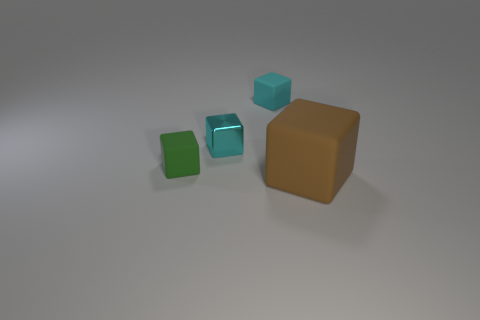Subtract all cyan rubber cubes. How many cubes are left? 3 Subtract all green cubes. How many cubes are left? 3 Subtract 0 blue cylinders. How many objects are left? 4 Subtract 2 cubes. How many cubes are left? 2 Subtract all brown cubes. Subtract all red cylinders. How many cubes are left? 3 Subtract all brown cylinders. How many gray cubes are left? 0 Subtract all tiny red metallic cylinders. Subtract all large matte blocks. How many objects are left? 3 Add 1 matte cubes. How many matte cubes are left? 4 Add 1 small cyan blocks. How many small cyan blocks exist? 3 Add 1 small green things. How many objects exist? 5 